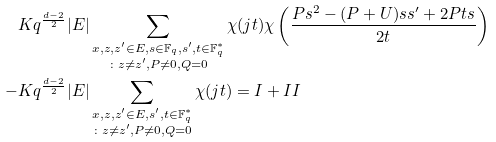<formula> <loc_0><loc_0><loc_500><loc_500>& K q ^ { \frac { d - 2 } { 2 } } | E | \sum _ { \substack { x , z , z ^ { \prime } \in E , s \in { \mathbb { F } } _ { q } , s ^ { \prime } , t \in { \mathbb { F } } _ { q } ^ { * } \\ \colon z \neq z ^ { \prime } , P \neq 0 , Q = 0 } } \chi ( j t ) \chi \left ( \frac { P s ^ { 2 } - ( P + U ) s s ^ { \prime } + 2 P t s } { 2 t } \right ) \\ - & K q ^ { \frac { d - 2 } { 2 } } | E | \sum _ { \substack { x , z , z ^ { \prime } \in E , s ^ { \prime } , t \in { \mathbb { F } } _ { q } ^ { * } \\ \colon z \neq z ^ { \prime } , P \neq 0 , Q = 0 } } \chi ( j t ) = I + I I</formula> 